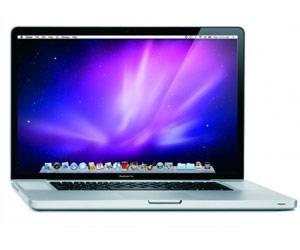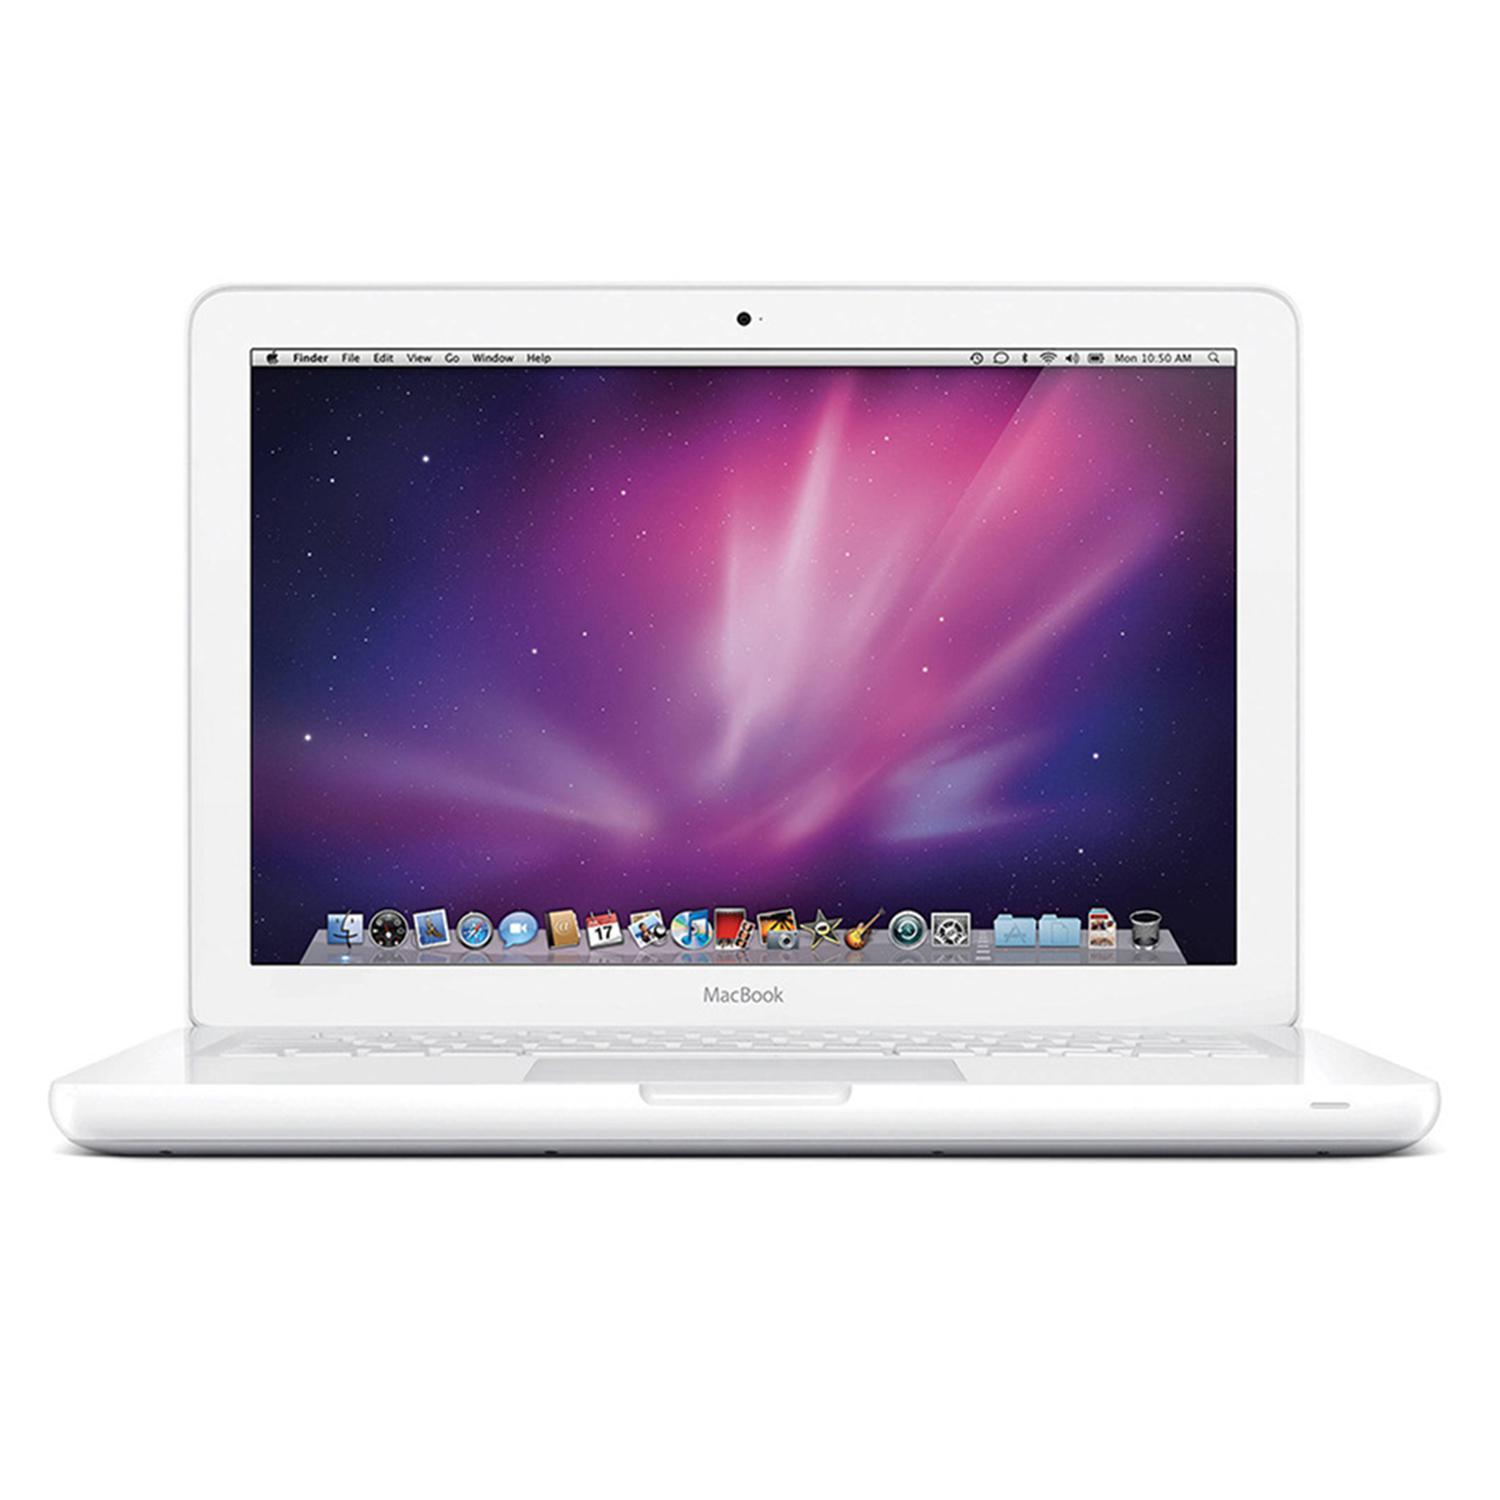The first image is the image on the left, the second image is the image on the right. Assess this claim about the two images: "Each image contains one device displayed so the screen is visible, and each screen has the same glowing violet and blue picture on it.". Correct or not? Answer yes or no. Yes. The first image is the image on the left, the second image is the image on the right. For the images shown, is this caption "The left and right image contains the same number of fully open laptops." true? Answer yes or no. Yes. 